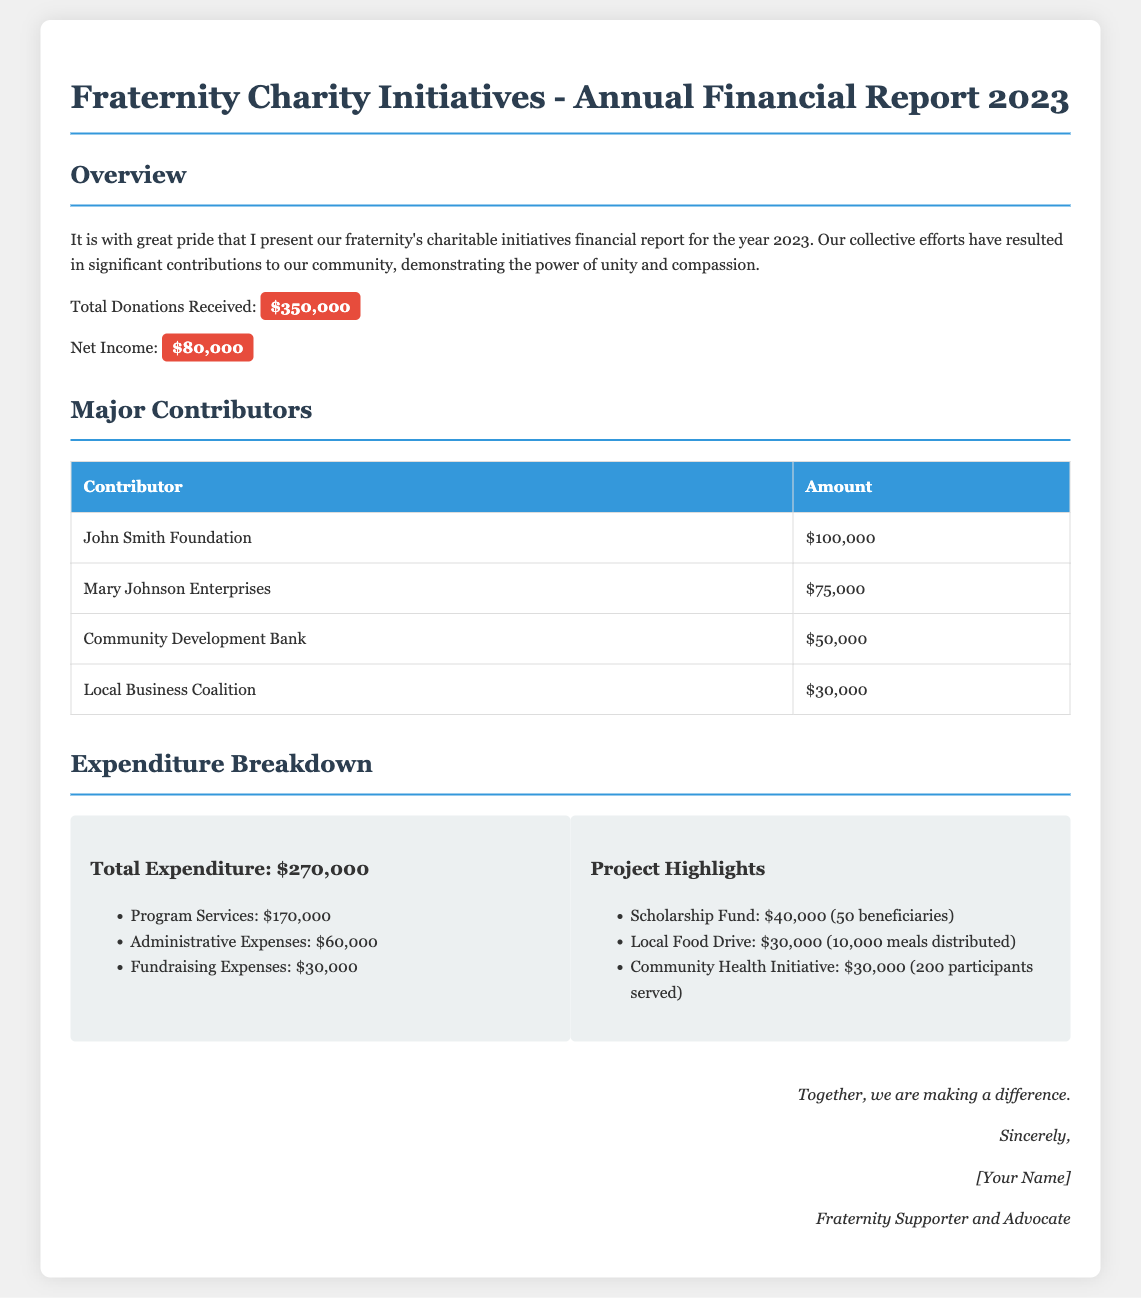What is the total amount of donations received? The total donations received is clearly stated in the overview section of the document.
Answer: $350,000 Who contributed the most to the fraternity's charity initiatives? The table of major contributors lists the contributors along with their respective amounts, highlighting the top contributor.
Answer: John Smith Foundation What was the net income for the year 2023? The net income is presented in the overview, showing the financial outcome after expenditures.
Answer: $80,000 How much was spent on program services? The expenditure breakdown specifies the allocation of funds, detailing the amount designated for program services.
Answer: $170,000 What percentage of total expenditure was allocated to administrative expenses? By comparing administrative expenses with the total expenditure, one can calculate the specific financial allocation as a percentage.
Answer: 22.22% How many beneficiaries were served by the scholarship fund? The project highlights section details the specific number of beneficiaries benefiting from the scholarship fund initiative.
Answer: 50 beneficiaries What was the total expenditure for the community health initiative? The project highlights section outlines the financial commitment towards different initiatives including the community health initiative.
Answer: $30,000 What was the total amount spent on fundraising expenses? The expenditure breakdown provides specific amounts allocated to different areas, including fundraising expenses.
Answer: $30,000 What is the total number of meals distributed in the local food drive? The details in the project highlights mention the specific number of meals provided in that initiative.
Answer: 10,000 meals distributed 